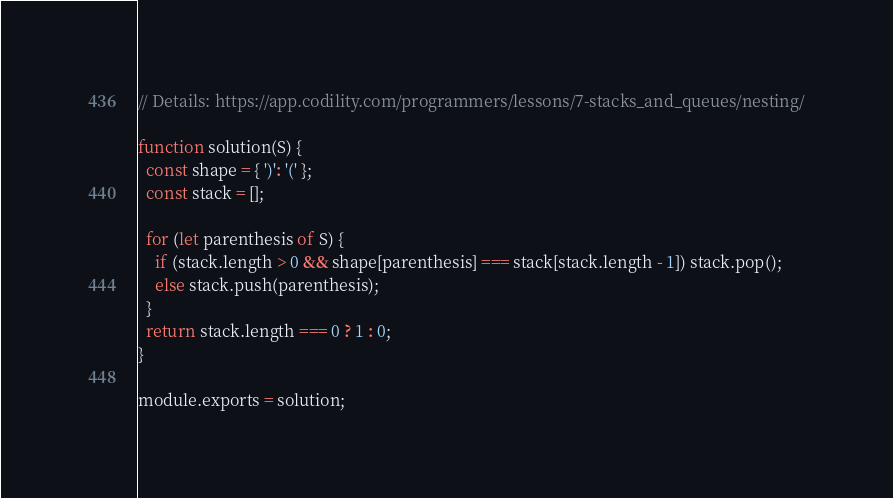Convert code to text. <code><loc_0><loc_0><loc_500><loc_500><_JavaScript_>// Details: https://app.codility.com/programmers/lessons/7-stacks_and_queues/nesting/

function solution(S) {
  const shape = { ')': '(' };
  const stack = [];

  for (let parenthesis of S) {
    if (stack.length > 0 && shape[parenthesis] === stack[stack.length - 1]) stack.pop();
    else stack.push(parenthesis);
  }
  return stack.length === 0 ? 1 : 0;
}

module.exports = solution;
</code> 